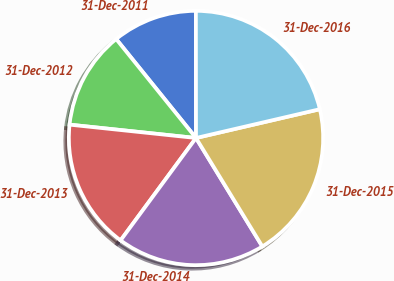Convert chart. <chart><loc_0><loc_0><loc_500><loc_500><pie_chart><fcel>31-Dec-2011<fcel>31-Dec-2012<fcel>31-Dec-2013<fcel>31-Dec-2014<fcel>31-Dec-2015<fcel>31-Dec-2016<nl><fcel>10.79%<fcel>12.52%<fcel>16.57%<fcel>18.84%<fcel>19.9%<fcel>21.38%<nl></chart> 